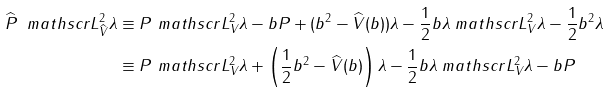Convert formula to latex. <formula><loc_0><loc_0><loc_500><loc_500>\widehat { P } \ m a t h s c r { L } _ { \widehat { V } } ^ { 2 } \lambda & \equiv P \ m a t h s c r { L } _ { V } ^ { 2 } \lambda - b P + ( b ^ { 2 } - \widehat { V } ( b ) ) \lambda - \frac { 1 } { 2 } b \lambda \ m a t h s c r { L } _ { V } ^ { 2 } \lambda - \frac { 1 } { 2 } b ^ { 2 } \lambda \\ & \equiv P \ m a t h s c r { L } _ { V } ^ { 2 } \lambda + \left ( \frac { 1 } { 2 } b ^ { 2 } - \widehat { V } ( b ) \right ) \lambda - \frac { 1 } { 2 } b \lambda \ m a t h s c r { L } _ { V } ^ { 2 } \lambda - b P</formula> 